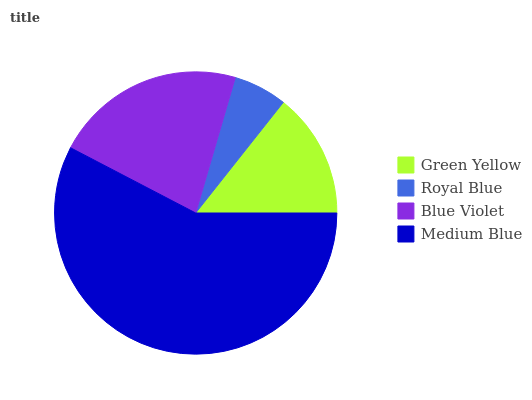Is Royal Blue the minimum?
Answer yes or no. Yes. Is Medium Blue the maximum?
Answer yes or no. Yes. Is Blue Violet the minimum?
Answer yes or no. No. Is Blue Violet the maximum?
Answer yes or no. No. Is Blue Violet greater than Royal Blue?
Answer yes or no. Yes. Is Royal Blue less than Blue Violet?
Answer yes or no. Yes. Is Royal Blue greater than Blue Violet?
Answer yes or no. No. Is Blue Violet less than Royal Blue?
Answer yes or no. No. Is Blue Violet the high median?
Answer yes or no. Yes. Is Green Yellow the low median?
Answer yes or no. Yes. Is Royal Blue the high median?
Answer yes or no. No. Is Royal Blue the low median?
Answer yes or no. No. 